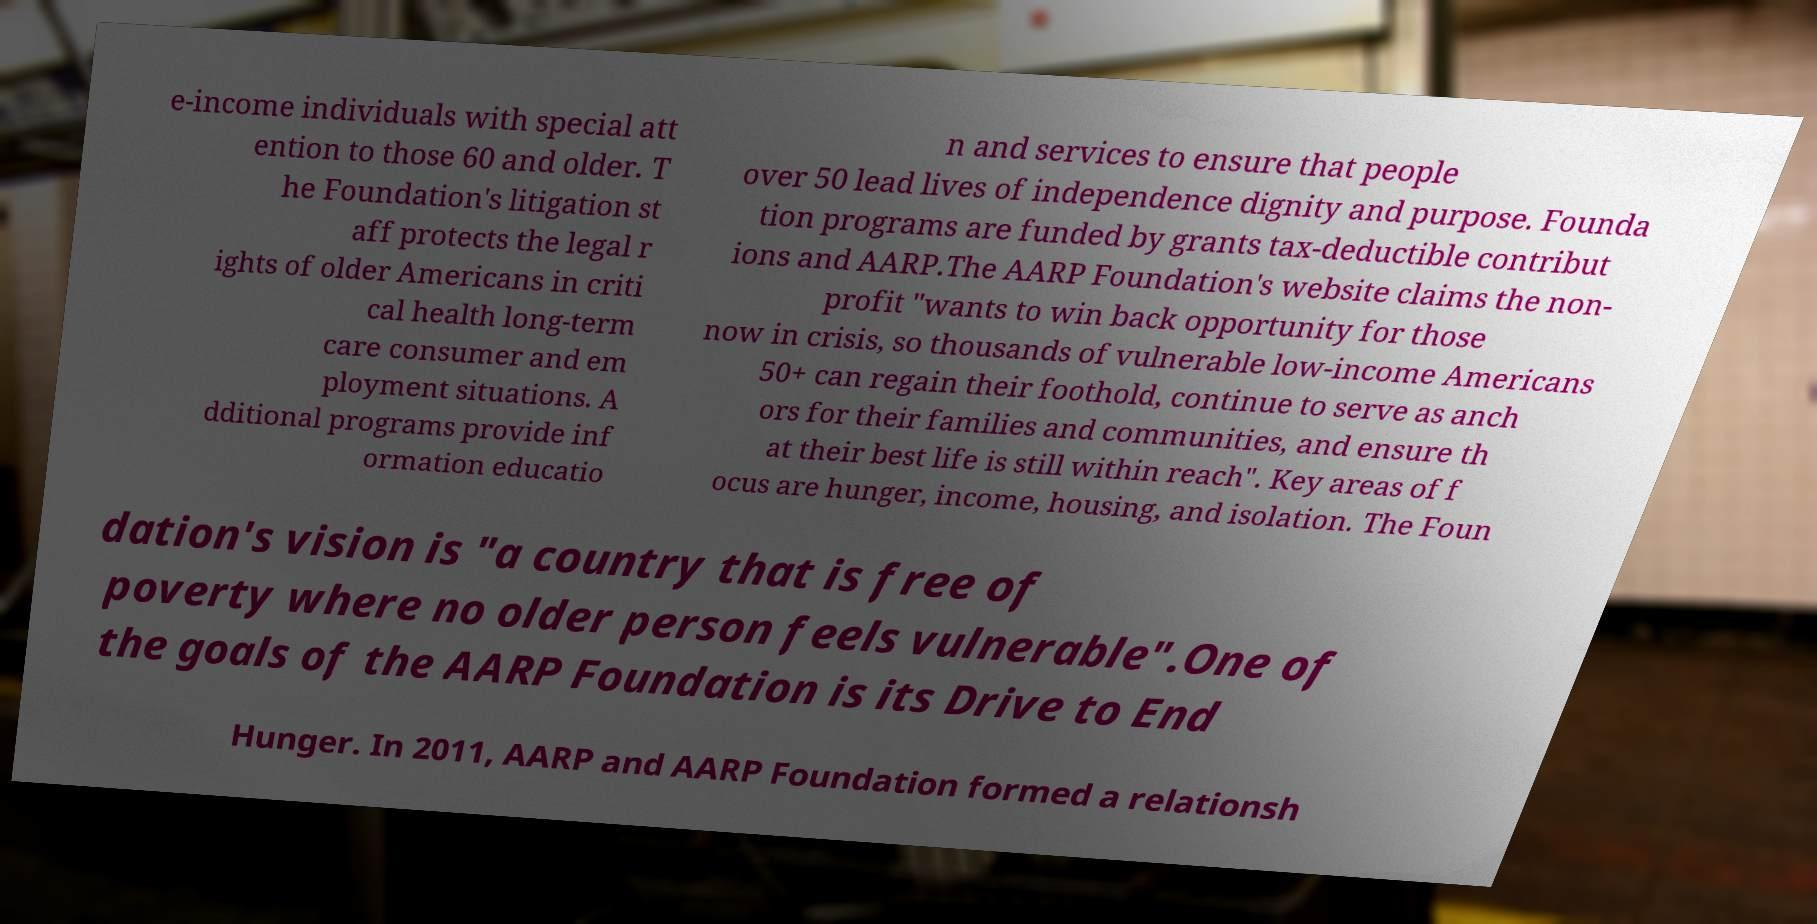I need the written content from this picture converted into text. Can you do that? e-income individuals with special att ention to those 60 and older. T he Foundation's litigation st aff protects the legal r ights of older Americans in criti cal health long-term care consumer and em ployment situations. A dditional programs provide inf ormation educatio n and services to ensure that people over 50 lead lives of independence dignity and purpose. Founda tion programs are funded by grants tax-deductible contribut ions and AARP.The AARP Foundation's website claims the non- profit "wants to win back opportunity for those now in crisis, so thousands of vulnerable low-income Americans 50+ can regain their foothold, continue to serve as anch ors for their families and communities, and ensure th at their best life is still within reach". Key areas of f ocus are hunger, income, housing, and isolation. The Foun dation's vision is "a country that is free of poverty where no older person feels vulnerable".One of the goals of the AARP Foundation is its Drive to End Hunger. In 2011, AARP and AARP Foundation formed a relationsh 